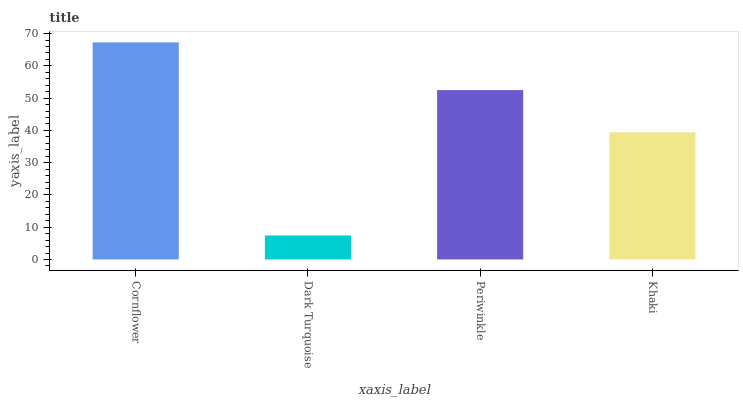Is Dark Turquoise the minimum?
Answer yes or no. Yes. Is Cornflower the maximum?
Answer yes or no. Yes. Is Periwinkle the minimum?
Answer yes or no. No. Is Periwinkle the maximum?
Answer yes or no. No. Is Periwinkle greater than Dark Turquoise?
Answer yes or no. Yes. Is Dark Turquoise less than Periwinkle?
Answer yes or no. Yes. Is Dark Turquoise greater than Periwinkle?
Answer yes or no. No. Is Periwinkle less than Dark Turquoise?
Answer yes or no. No. Is Periwinkle the high median?
Answer yes or no. Yes. Is Khaki the low median?
Answer yes or no. Yes. Is Khaki the high median?
Answer yes or no. No. Is Cornflower the low median?
Answer yes or no. No. 